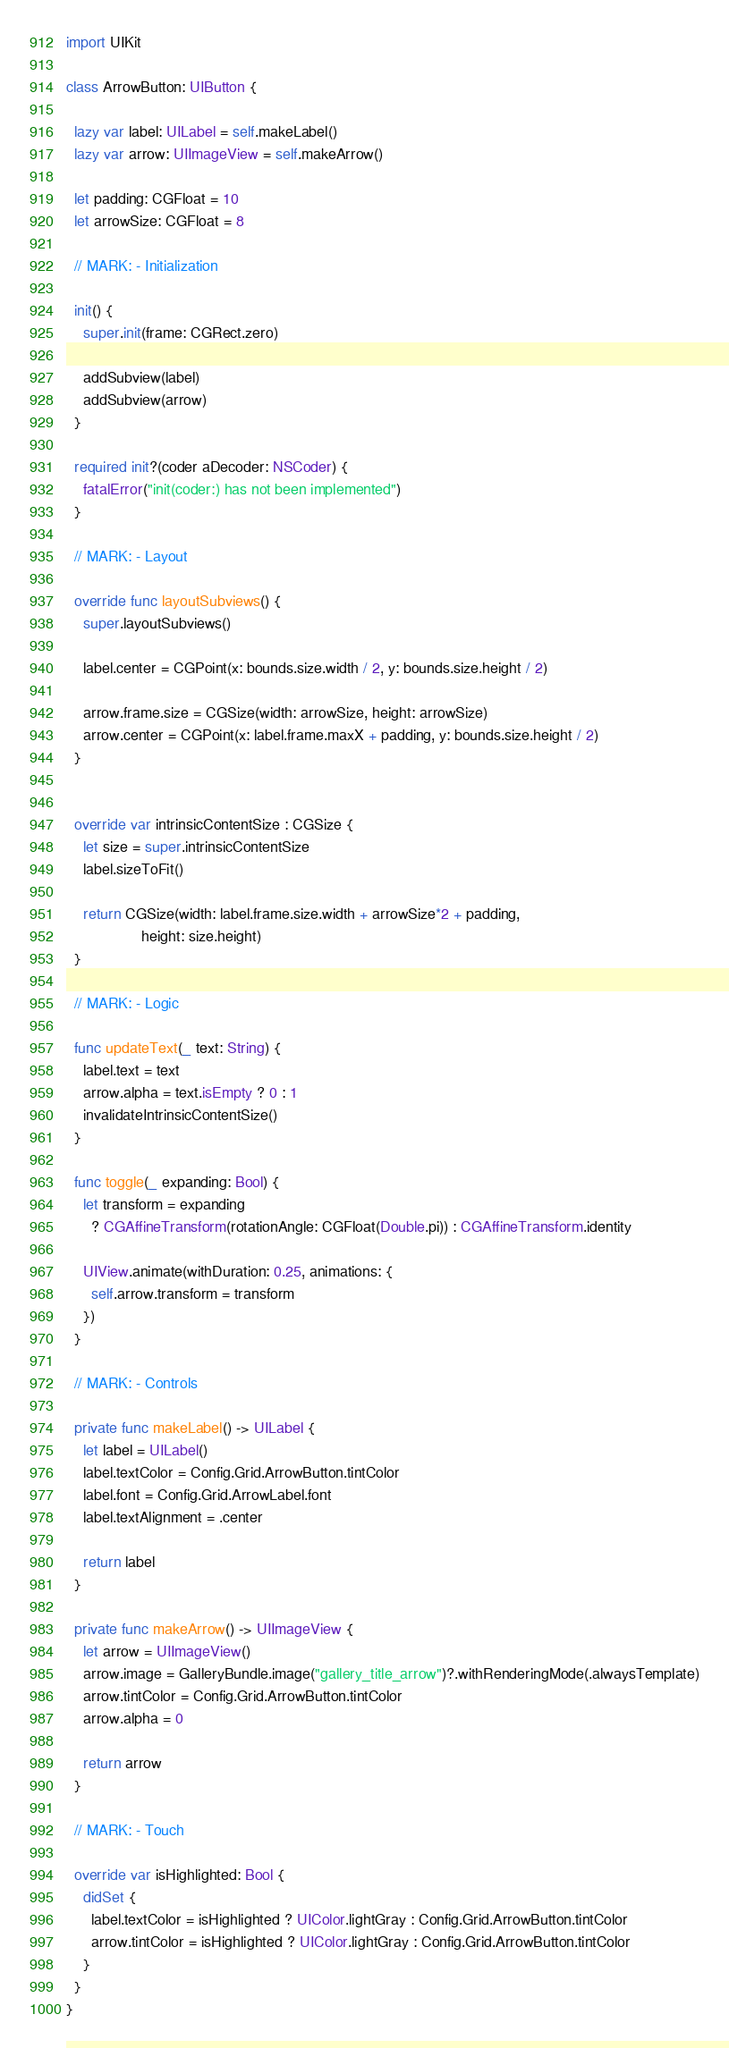Convert code to text. <code><loc_0><loc_0><loc_500><loc_500><_Swift_>import UIKit

class ArrowButton: UIButton {

  lazy var label: UILabel = self.makeLabel()
  lazy var arrow: UIImageView = self.makeArrow()

  let padding: CGFloat = 10
  let arrowSize: CGFloat = 8

  // MARK: - Initialization

  init() {
    super.init(frame: CGRect.zero)

    addSubview(label)
    addSubview(arrow)
  }

  required init?(coder aDecoder: NSCoder) {
    fatalError("init(coder:) has not been implemented")
  }

  // MARK: - Layout

  override func layoutSubviews() {
    super.layoutSubviews()

    label.center = CGPoint(x: bounds.size.width / 2, y: bounds.size.height / 2)

    arrow.frame.size = CGSize(width: arrowSize, height: arrowSize)
    arrow.center = CGPoint(x: label.frame.maxX + padding, y: bounds.size.height / 2)
  }


  override var intrinsicContentSize : CGSize {
    let size = super.intrinsicContentSize
    label.sizeToFit()

    return CGSize(width: label.frame.size.width + arrowSize*2 + padding,
                  height: size.height)
  }

  // MARK: - Logic

  func updateText(_ text: String) {
    label.text = text
    arrow.alpha = text.isEmpty ? 0 : 1
    invalidateIntrinsicContentSize()
  }

  func toggle(_ expanding: Bool) {
    let transform = expanding
      ? CGAffineTransform(rotationAngle: CGFloat(Double.pi)) : CGAffineTransform.identity
    
    UIView.animate(withDuration: 0.25, animations: {
      self.arrow.transform = transform
    }) 
  }

  // MARK: - Controls

  private func makeLabel() -> UILabel {
    let label = UILabel()
    label.textColor = Config.Grid.ArrowButton.tintColor
    label.font = Config.Grid.ArrowLabel.font
    label.textAlignment = .center

    return label
  }

  private func makeArrow() -> UIImageView {
    let arrow = UIImageView()
    arrow.image = GalleryBundle.image("gallery_title_arrow")?.withRenderingMode(.alwaysTemplate)
    arrow.tintColor = Config.Grid.ArrowButton.tintColor
    arrow.alpha = 0

    return arrow
  }

  // MARK: - Touch

  override var isHighlighted: Bool {
    didSet {
      label.textColor = isHighlighted ? UIColor.lightGray : Config.Grid.ArrowButton.tintColor
      arrow.tintColor = isHighlighted ? UIColor.lightGray : Config.Grid.ArrowButton.tintColor
    }
  }
}
</code> 